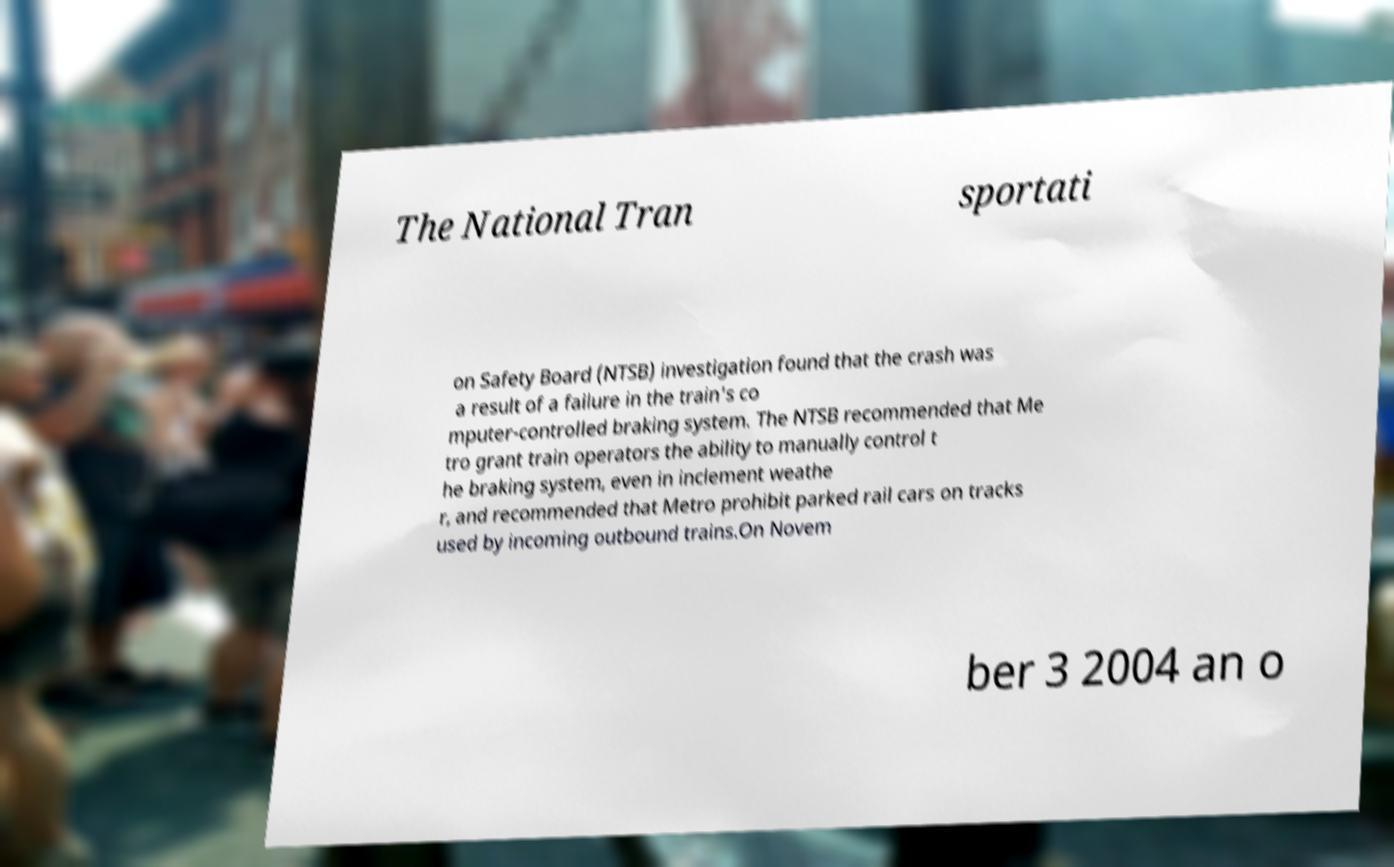There's text embedded in this image that I need extracted. Can you transcribe it verbatim? The National Tran sportati on Safety Board (NTSB) investigation found that the crash was a result of a failure in the train's co mputer-controlled braking system. The NTSB recommended that Me tro grant train operators the ability to manually control t he braking system, even in inclement weathe r, and recommended that Metro prohibit parked rail cars on tracks used by incoming outbound trains.On Novem ber 3 2004 an o 